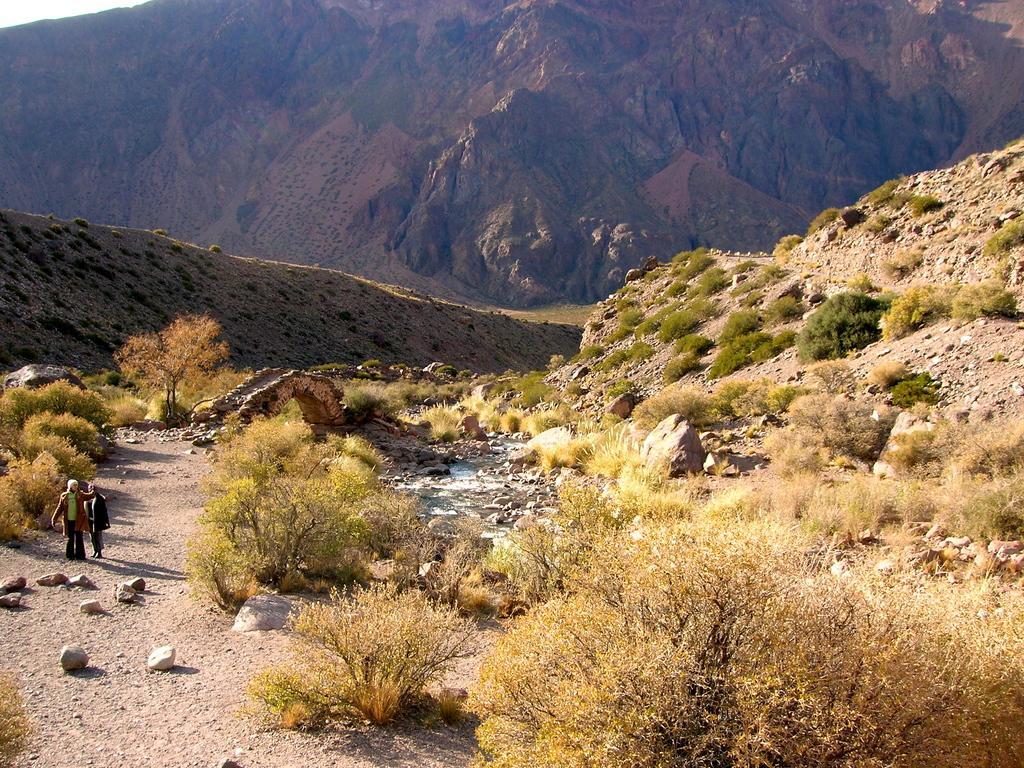Describe this image in one or two sentences. In this picture we can see two persons are standing on the left side, there are some plants in the front, at the bottom we can see some stones, there is a rock in the middle, in the background we can see a hill. 